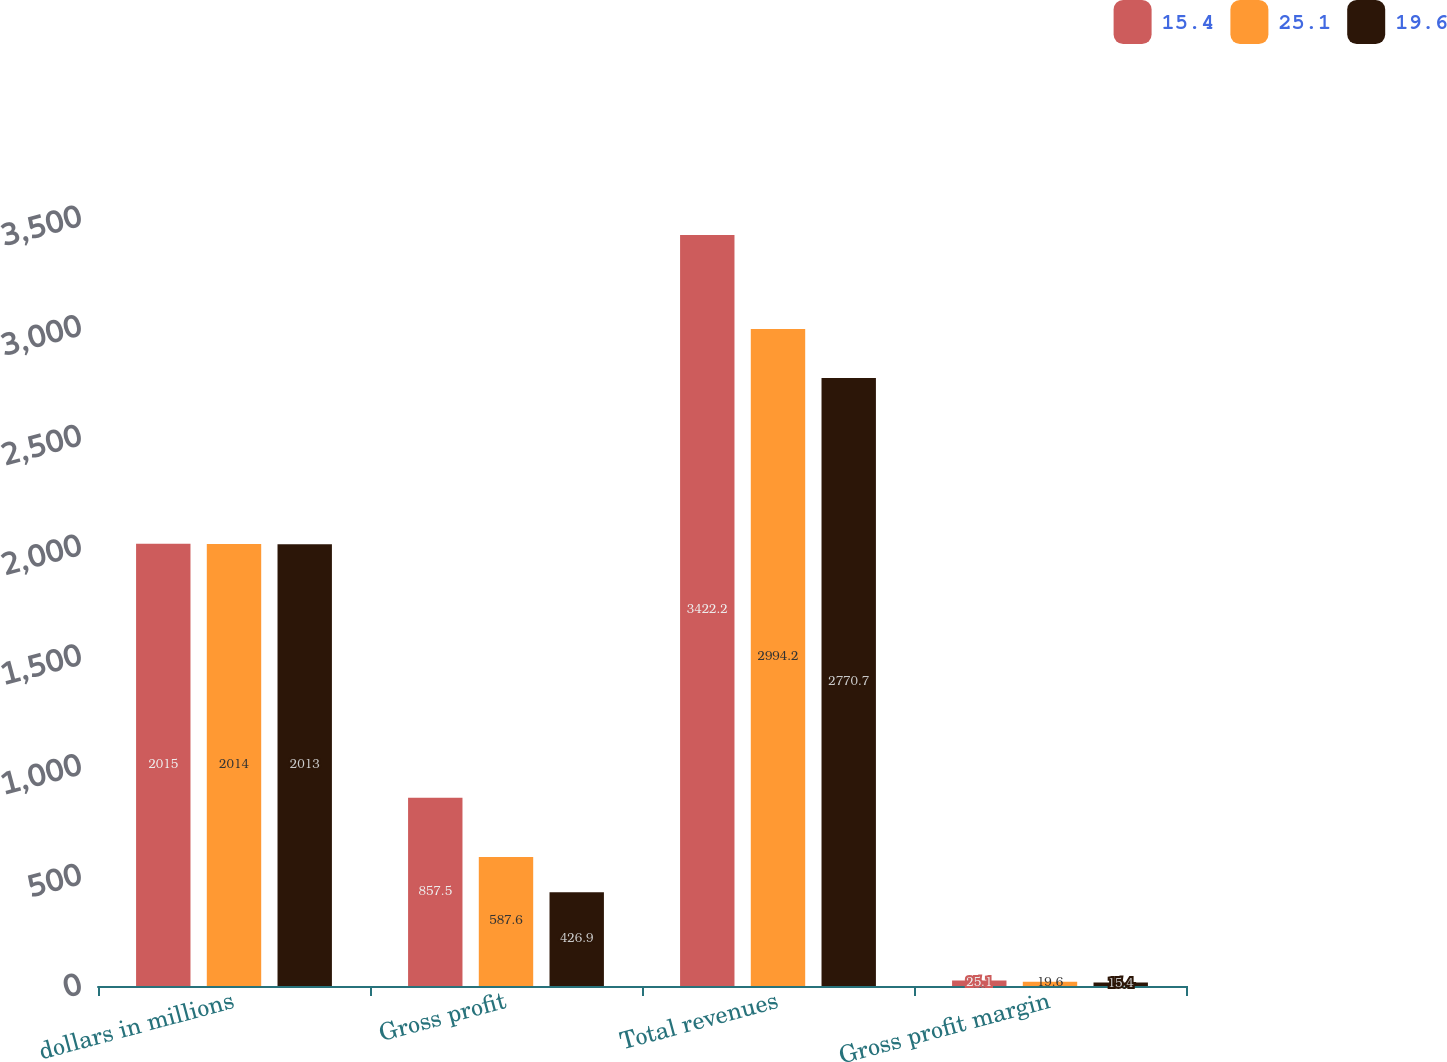Convert chart to OTSL. <chart><loc_0><loc_0><loc_500><loc_500><stacked_bar_chart><ecel><fcel>dollars in millions<fcel>Gross profit<fcel>Total revenues<fcel>Gross profit margin<nl><fcel>15.4<fcel>2015<fcel>857.5<fcel>3422.2<fcel>25.1<nl><fcel>25.1<fcel>2014<fcel>587.6<fcel>2994.2<fcel>19.6<nl><fcel>19.6<fcel>2013<fcel>426.9<fcel>2770.7<fcel>15.4<nl></chart> 